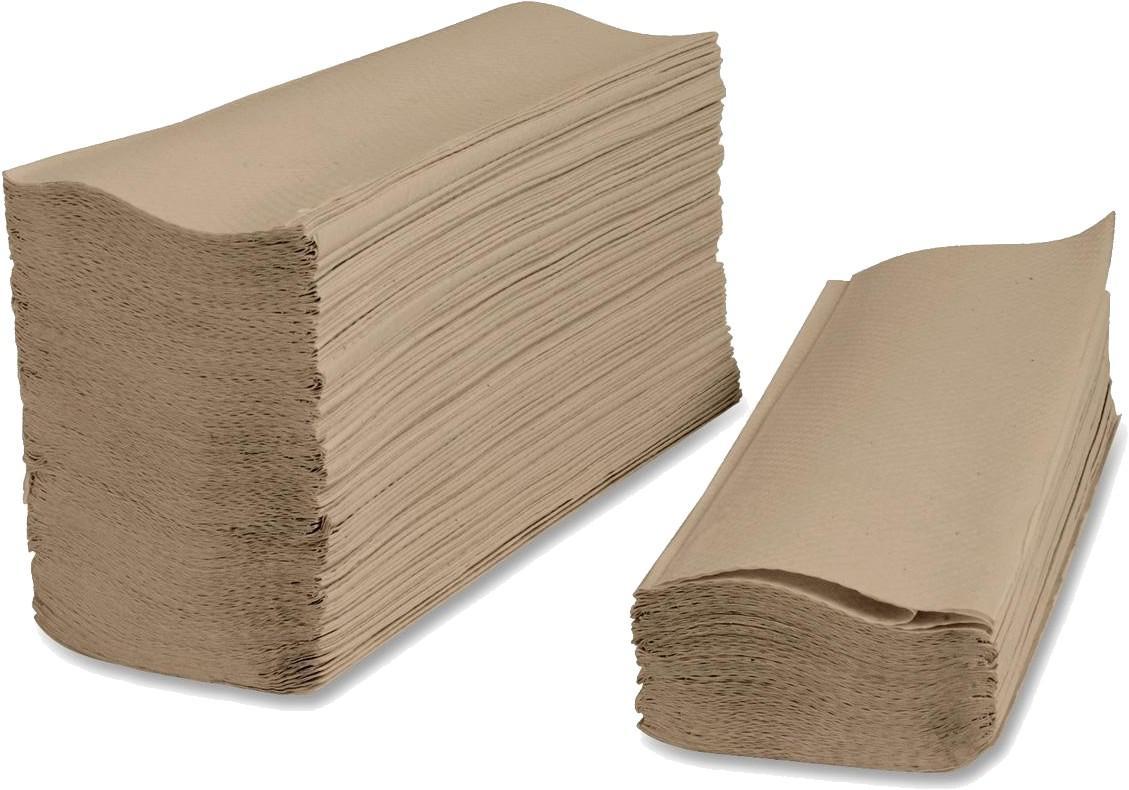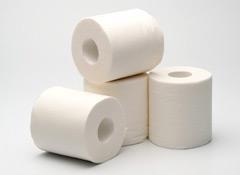The first image is the image on the left, the second image is the image on the right. Evaluate the accuracy of this statement regarding the images: "An image shows only flat, folded paper towels.". Is it true? Answer yes or no. Yes. The first image is the image on the left, the second image is the image on the right. Assess this claim about the two images: "All paper towels are white and on rolls.". Correct or not? Answer yes or no. No. 